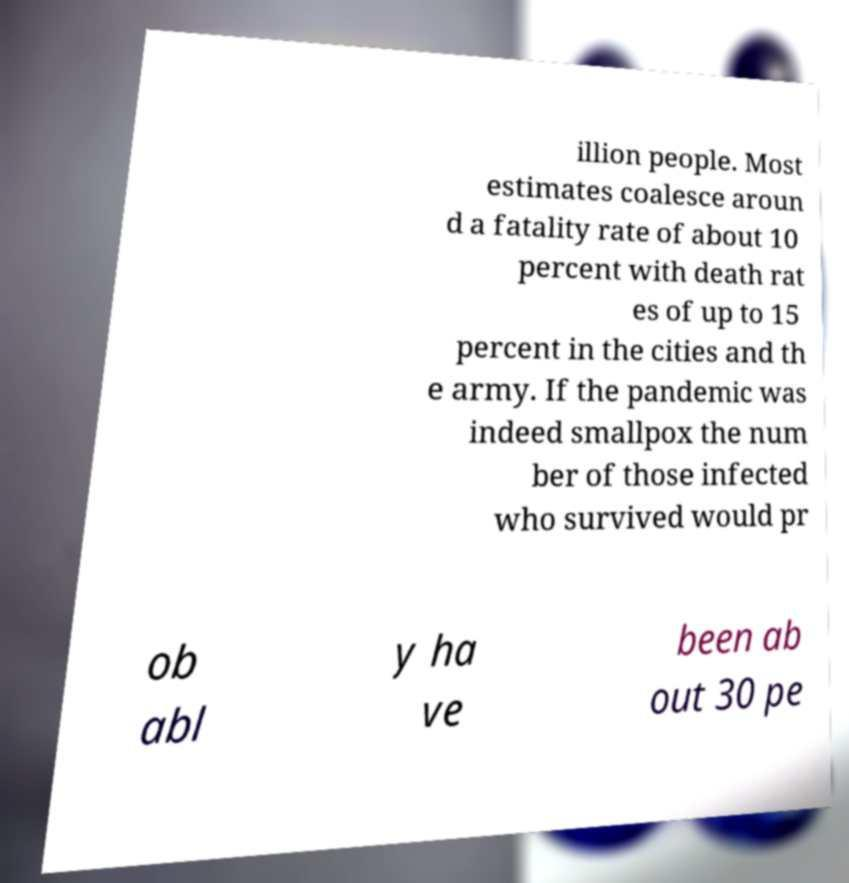I need the written content from this picture converted into text. Can you do that? illion people. Most estimates coalesce aroun d a fatality rate of about 10 percent with death rat es of up to 15 percent in the cities and th e army. If the pandemic was indeed smallpox the num ber of those infected who survived would pr ob abl y ha ve been ab out 30 pe 